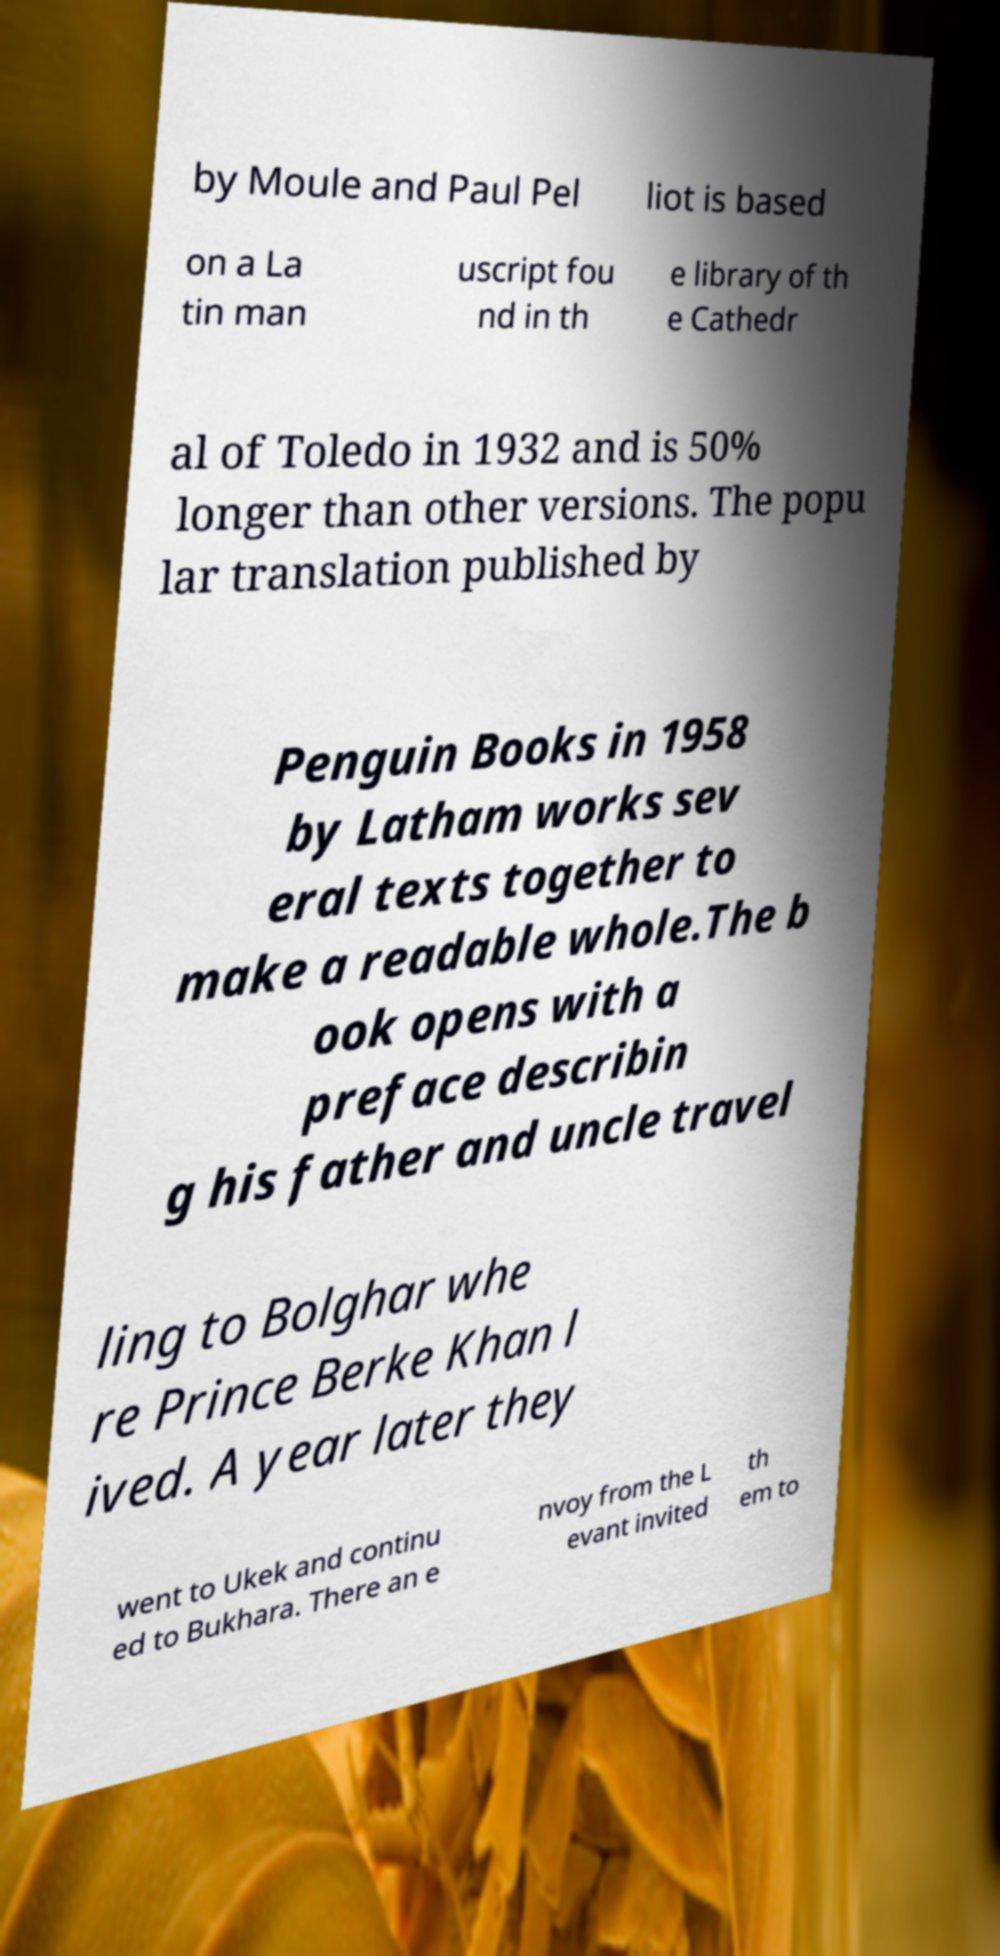Can you accurately transcribe the text from the provided image for me? by Moule and Paul Pel liot is based on a La tin man uscript fou nd in th e library of th e Cathedr al of Toledo in 1932 and is 50% longer than other versions. The popu lar translation published by Penguin Books in 1958 by Latham works sev eral texts together to make a readable whole.The b ook opens with a preface describin g his father and uncle travel ling to Bolghar whe re Prince Berke Khan l ived. A year later they went to Ukek and continu ed to Bukhara. There an e nvoy from the L evant invited th em to 